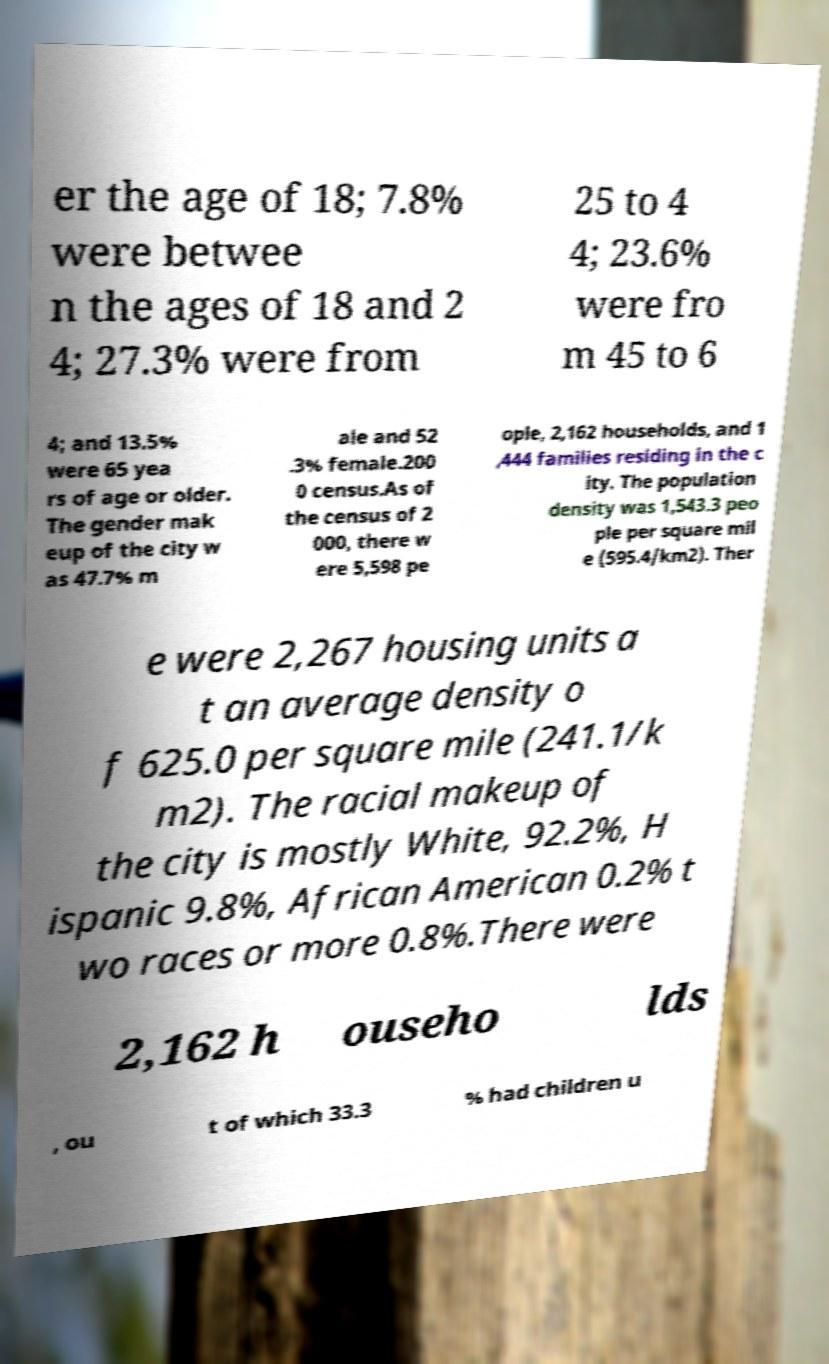There's text embedded in this image that I need extracted. Can you transcribe it verbatim? er the age of 18; 7.8% were betwee n the ages of 18 and 2 4; 27.3% were from 25 to 4 4; 23.6% were fro m 45 to 6 4; and 13.5% were 65 yea rs of age or older. The gender mak eup of the city w as 47.7% m ale and 52 .3% female.200 0 census.As of the census of 2 000, there w ere 5,598 pe ople, 2,162 households, and 1 ,444 families residing in the c ity. The population density was 1,543.3 peo ple per square mil e (595.4/km2). Ther e were 2,267 housing units a t an average density o f 625.0 per square mile (241.1/k m2). The racial makeup of the city is mostly White, 92.2%, H ispanic 9.8%, African American 0.2% t wo races or more 0.8%.There were 2,162 h ouseho lds , ou t of which 33.3 % had children u 